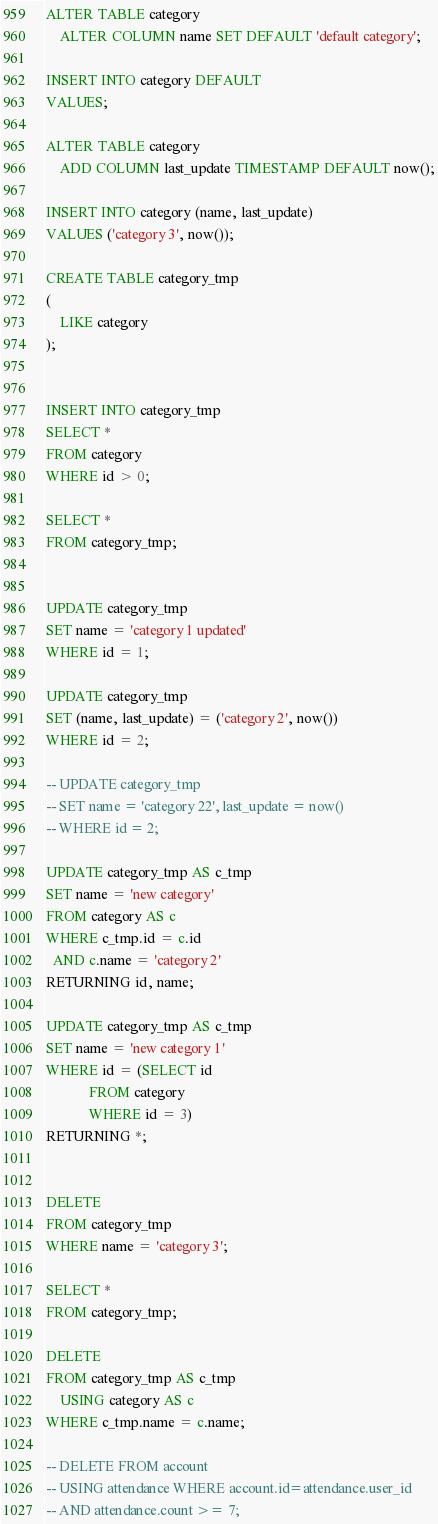<code> <loc_0><loc_0><loc_500><loc_500><_SQL_>
ALTER TABLE category
    ALTER COLUMN name SET DEFAULT 'default category';

INSERT INTO category DEFAULT
VALUES;

ALTER TABLE category
    ADD COLUMN last_update TIMESTAMP DEFAULT now();

INSERT INTO category (name, last_update)
VALUES ('category 3', now());

CREATE TABLE category_tmp
(
    LIKE category
);


INSERT INTO category_tmp
SELECT *
FROM category
WHERE id > 0;

SELECT *
FROM category_tmp;


UPDATE category_tmp
SET name = 'category 1 updated'
WHERE id = 1;

UPDATE category_tmp
SET (name, last_update) = ('category 2', now())
WHERE id = 2;

-- UPDATE category_tmp
-- SET name = 'category 22', last_update = now()
-- WHERE id = 2;

UPDATE category_tmp AS c_tmp
SET name = 'new category'
FROM category AS c
WHERE c_tmp.id = c.id
  AND c.name = 'category 2'
RETURNING id, name;

UPDATE category_tmp AS c_tmp
SET name = 'new category 1'
WHERE id = (SELECT id
            FROM category
            WHERE id = 3)
RETURNING *;


DELETE
FROM category_tmp
WHERE name = 'category 3';

SELECT *
FROM category_tmp;

DELETE
FROM category_tmp AS c_tmp
    USING category AS c
WHERE c_tmp.name = c.name;

-- DELETE FROM account
-- USING attendance WHERE account.id=attendance.user_id
-- AND attendance.count >= 7;
</code> 